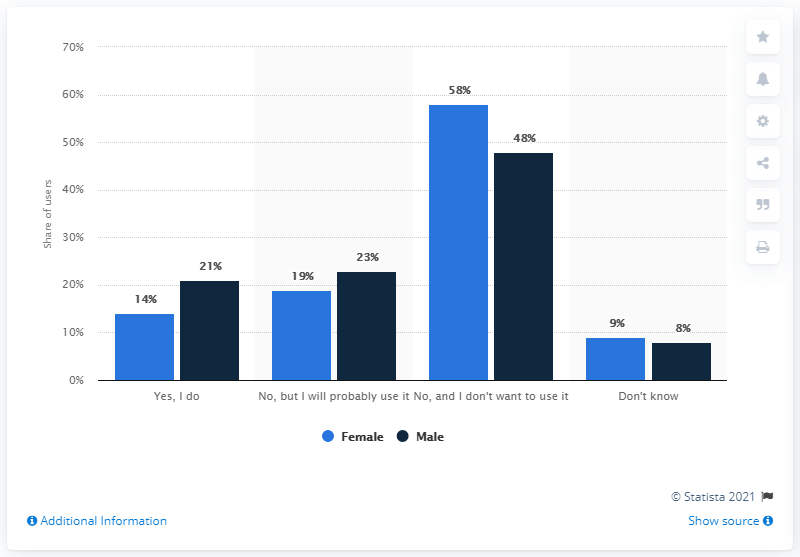Specify some key components in this picture. What is the difference between the average of "Yes, I do" and the average of the two highest values, 35.5? It is not accurate to say that women have higher value in all categories. 